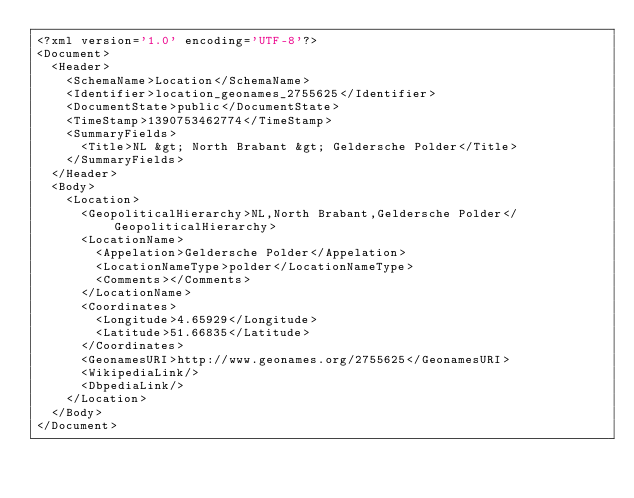<code> <loc_0><loc_0><loc_500><loc_500><_XML_><?xml version='1.0' encoding='UTF-8'?>
<Document>
  <Header>
    <SchemaName>Location</SchemaName>
    <Identifier>location_geonames_2755625</Identifier>
    <DocumentState>public</DocumentState>
    <TimeStamp>1390753462774</TimeStamp>
    <SummaryFields>
      <Title>NL &gt; North Brabant &gt; Geldersche Polder</Title>
    </SummaryFields>
  </Header>
  <Body>
    <Location>
      <GeopoliticalHierarchy>NL,North Brabant,Geldersche Polder</GeopoliticalHierarchy>
      <LocationName>
        <Appelation>Geldersche Polder</Appelation>
        <LocationNameType>polder</LocationNameType>
        <Comments></Comments>
      </LocationName>
      <Coordinates>
        <Longitude>4.65929</Longitude>
        <Latitude>51.66835</Latitude>
      </Coordinates>
      <GeonamesURI>http://www.geonames.org/2755625</GeonamesURI>
      <WikipediaLink/>
      <DbpediaLink/>
    </Location>
  </Body>
</Document>
</code> 